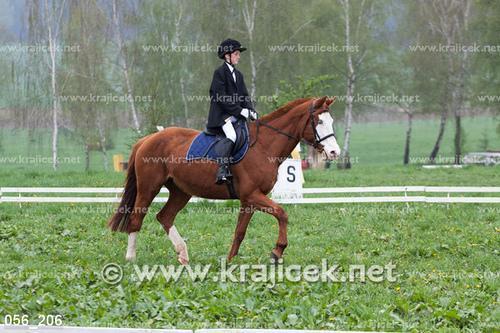How many horses?
Give a very brief answer. 1. 